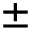Convert formula to latex. <formula><loc_0><loc_0><loc_500><loc_500>\pm</formula> 